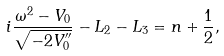Convert formula to latex. <formula><loc_0><loc_0><loc_500><loc_500>i \frac { \omega ^ { 2 } - V _ { 0 } } { \sqrt { - 2 V _ { 0 } ^ { \prime \prime } } } - L _ { 2 } - L _ { 3 } = n + \frac { 1 } { 2 } ,</formula> 